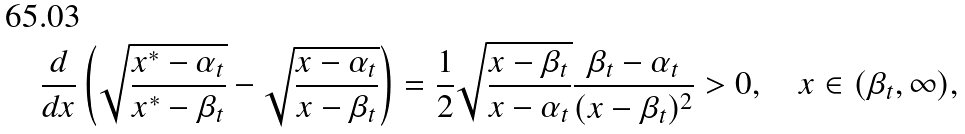Convert formula to latex. <formula><loc_0><loc_0><loc_500><loc_500>\frac { d } { d x } \left ( \sqrt { \frac { x ^ { \ast } - \alpha _ { t } } { x ^ { \ast } - \beta _ { t } } } - \sqrt { \frac { x - \alpha _ { t } } { x - \beta _ { t } } } \right ) = \frac { 1 } { 2 } \sqrt { \frac { x - \beta _ { t } } { x - \alpha _ { t } } } \frac { \beta _ { t } - \alpha _ { t } } { ( x - \beta _ { t } ) ^ { 2 } } > 0 , \quad x \in ( \beta _ { t } , \infty ) ,</formula> 